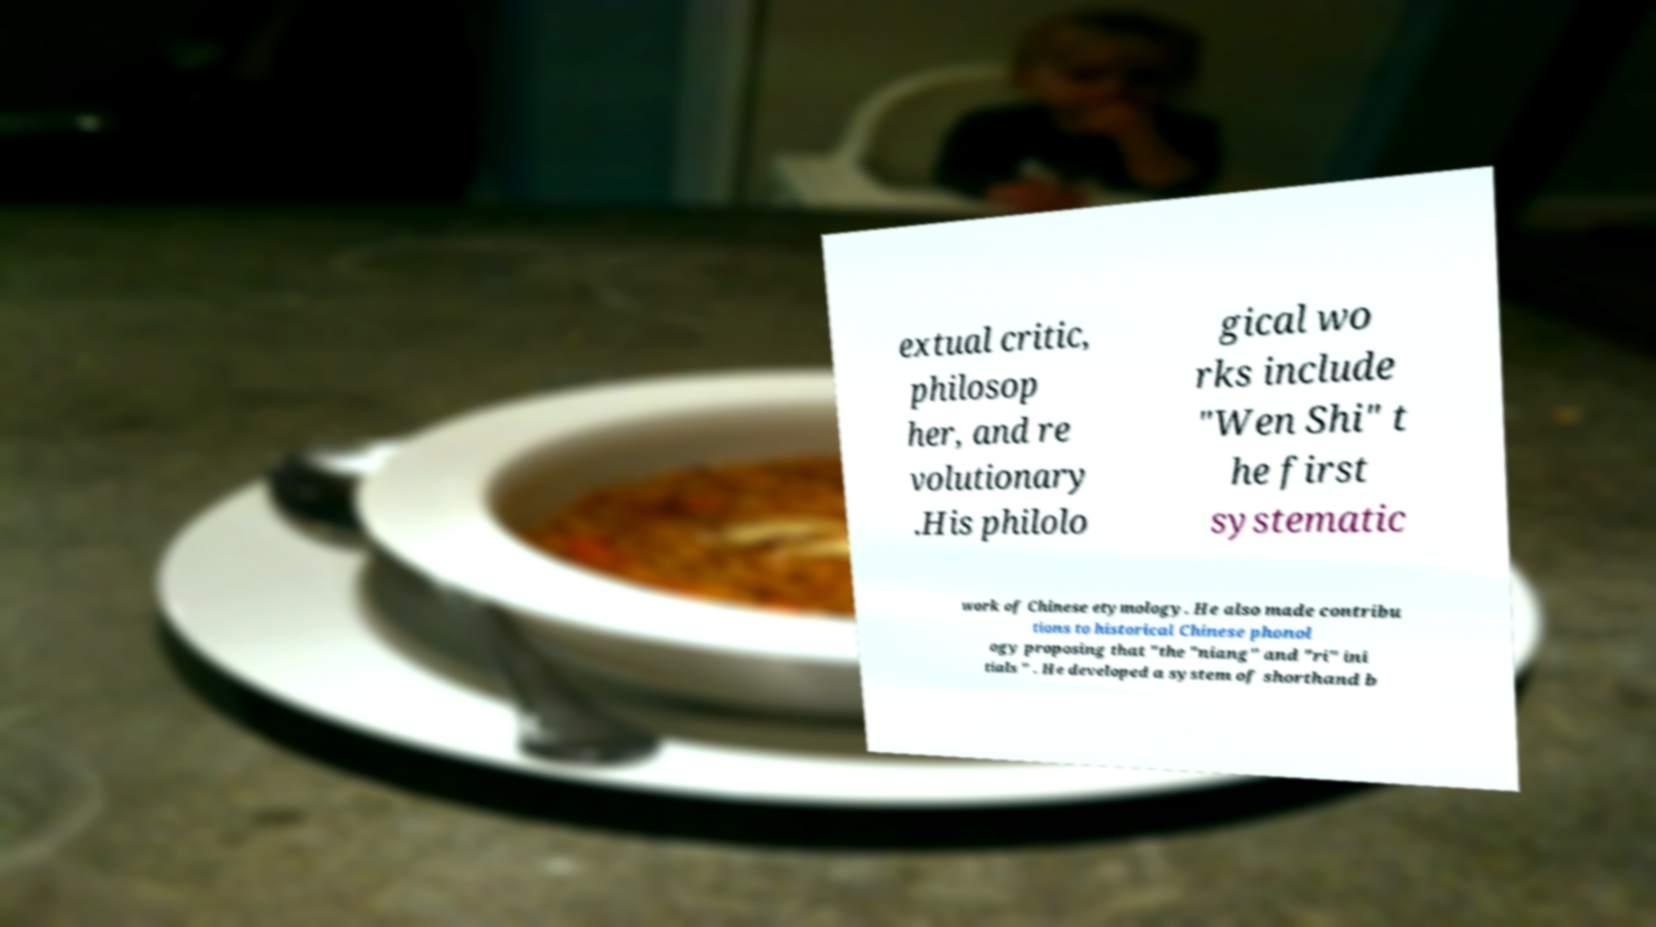Could you extract and type out the text from this image? extual critic, philosop her, and re volutionary .His philolo gical wo rks include "Wen Shi" t he first systematic work of Chinese etymology. He also made contribu tions to historical Chinese phonol ogy proposing that "the "niang" and "ri" ini tials " . He developed a system of shorthand b 